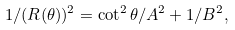Convert formula to latex. <formula><loc_0><loc_0><loc_500><loc_500>1 / ( R ( \theta ) ) ^ { 2 } = \cot ^ { 2 } \theta / A ^ { 2 } + 1 / B ^ { 2 } ,</formula> 